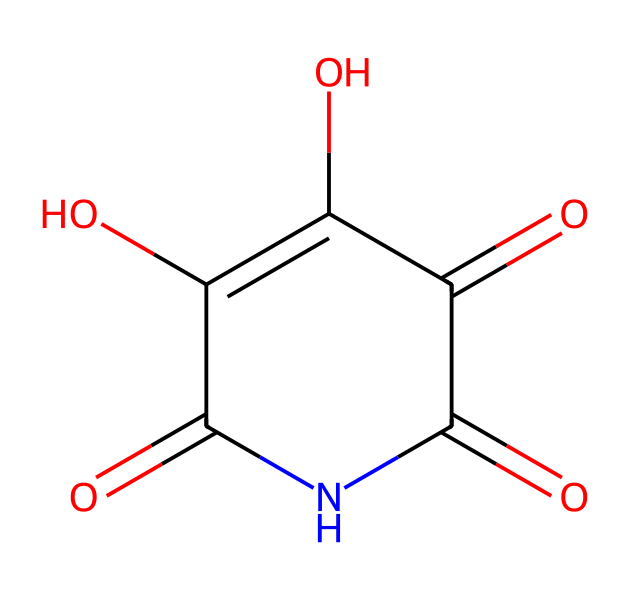How many carbon atoms are in this compound? By analyzing the SMILES representation, we can see that each carbon atom is represented within the structure. In this case, there are five carbon atoms connected in the ring structure of the imide, which can be counted directly from the SMILES notation.
Answer: five What functional groups are present in this chemical? Looking at the SMILES, we can identify carbonyl groups (C=O) as well as a hydroxyl group (C-OH) based on the structure's components. The presence of these distinct functionalities implies that it has both a carbonyl and a hydroxyl group.
Answer: carbonyl and hydroxyl Does this compound contain nitrogen? The SMILES representation includes 'N', which signifies the presence of a nitrogen atom in the structure. As a key component of imides, nitrogen is indeed present in this chemical.
Answer: yes What is the total number of rings in this chemical structure? From analyzing the SMILES notation, I can observe that there is one cyclic structure depicted in the representation. This indicates that the compound has a single ring.
Answer: one What type of imide is represented by this compound? Based on the chemical structure's characteristics, the compound appears to be a cyclic imide due to the connectivity of the atoms forming a ring that includes both carbon and nitrogen with carbonyl functionalities.
Answer: cyclic imide How many oxygen atoms are in this structure? By counting each 'O' in the SMILES notation, it indicates that there are three oxygen atoms connected to carbon atoms within the molecular structure, confirming the total count of oxygen atoms.
Answer: three 